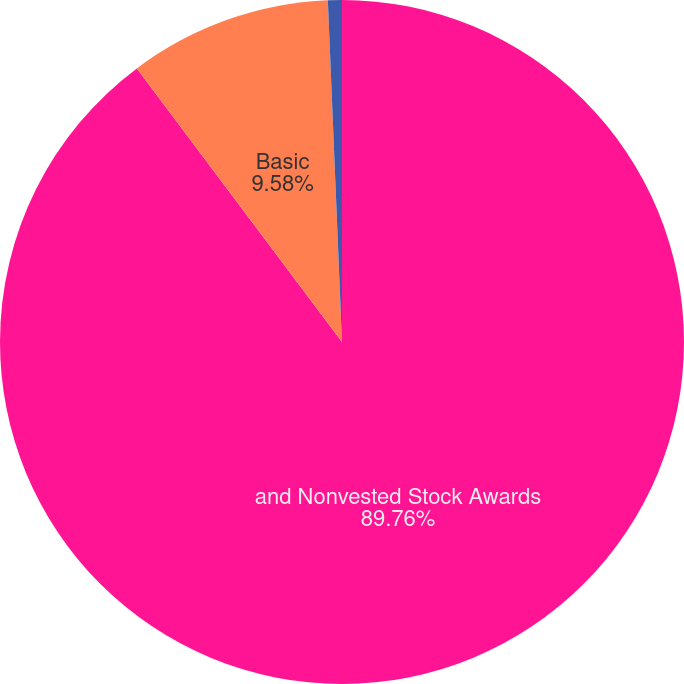<chart> <loc_0><loc_0><loc_500><loc_500><pie_chart><fcel>and Nonvested Stock Awards<fcel>Basic<fcel>Assuming Dilution<nl><fcel>89.76%<fcel>9.58%<fcel>0.66%<nl></chart> 